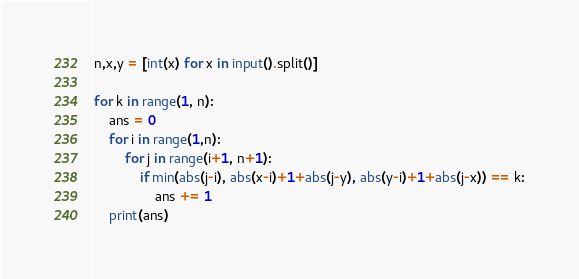Convert code to text. <code><loc_0><loc_0><loc_500><loc_500><_Python_>n,x,y = [int(x) for x in input().split()]

for k in range(1, n):
    ans = 0
    for i in range(1,n):
        for j in range(i+1, n+1):
            if min(abs(j-i), abs(x-i)+1+abs(j-y), abs(y-i)+1+abs(j-x)) == k:
                ans += 1
    print(ans)</code> 